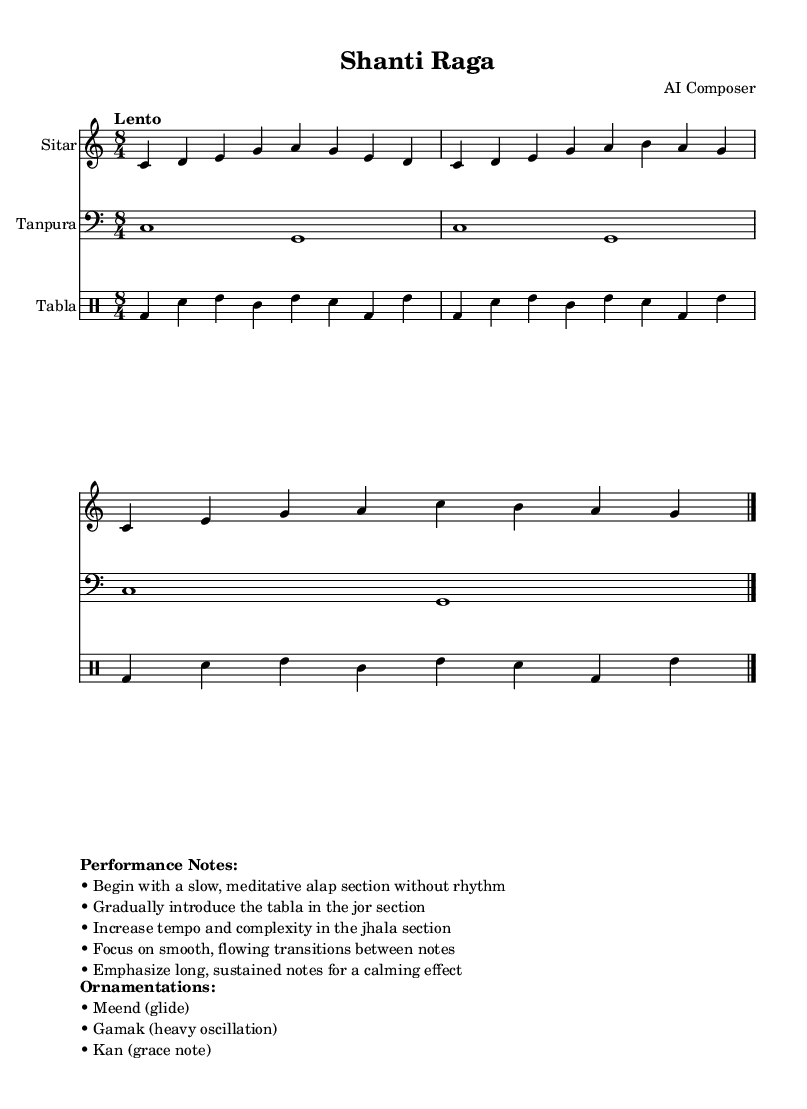What is the key signature of this music? The key signature is C major, which indicates no sharps or flats are present. This can be observed from the music notation where it displays a C note as the tonic without accidentals.
Answer: C major What is the time signature of this music? The time signature is 8/4, which is indicated at the beginning of the score. This means there are eight beats in a measure, and each beat is a quarter note.
Answer: 8/4 What is the tempo marking of this piece? The tempo marking is "Lento," which translates to a slow and relaxed pace. This is specifically noted in the music notation at the start of the score.
Answer: Lento In which section does the tabla begin to play? The tabla begins to play in the jor section, which follows the slow, meditative alap section. This section is characterized by an introduction of rhythm that enhances the meditative quality.
Answer: Jor How many total measures are in the sitar part? The sitar part has three measures of music before the final double bar line, as seen in the structuring of the notes throughout the score.
Answer: Three measures What types of ornamentations are mentioned for this raga? The ornamentations include meend (glide), gamak (heavy oscillation), and kan (grace note). These techniques add expressiveness and are noted at the bottom of the sheet music as performance notes.
Answer: Meend, gamak, kan What is the main character of the alap section? The alap section is characterized as slow and meditative, with no rhythm, focusing solely on establishing the mood and framework of the raga. This is mentioned in the performance notes provided in the score.
Answer: Slow and meditative 